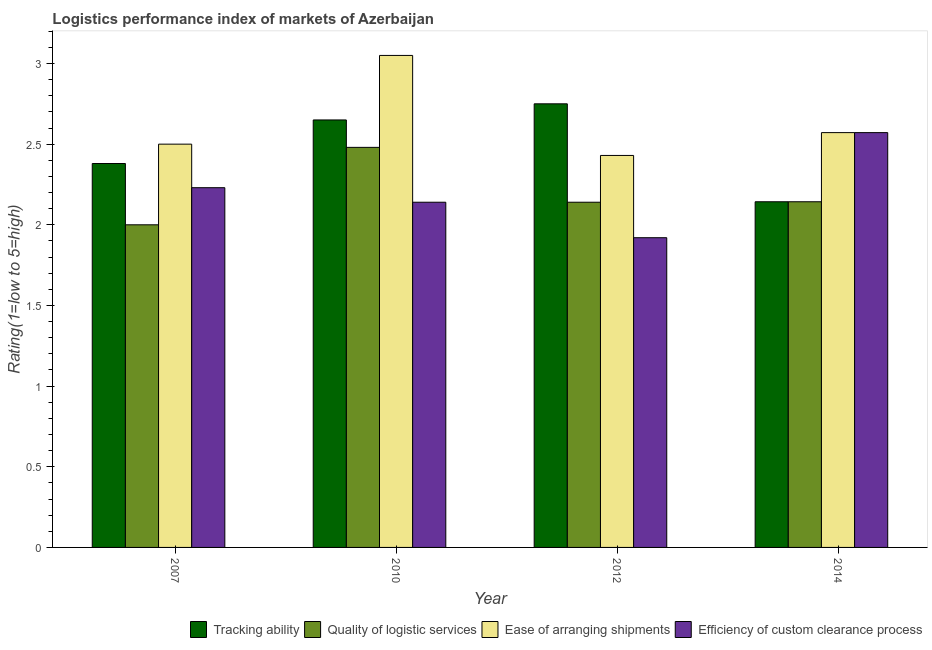How many groups of bars are there?
Keep it short and to the point. 4. Are the number of bars on each tick of the X-axis equal?
Make the answer very short. Yes. How many bars are there on the 1st tick from the left?
Offer a terse response. 4. How many bars are there on the 2nd tick from the right?
Your response must be concise. 4. What is the lpi rating of efficiency of custom clearance process in 2014?
Keep it short and to the point. 2.57. Across all years, what is the maximum lpi rating of ease of arranging shipments?
Offer a terse response. 3.05. Across all years, what is the minimum lpi rating of ease of arranging shipments?
Make the answer very short. 2.43. In which year was the lpi rating of ease of arranging shipments maximum?
Provide a short and direct response. 2010. In which year was the lpi rating of tracking ability minimum?
Your answer should be compact. 2014. What is the total lpi rating of quality of logistic services in the graph?
Provide a short and direct response. 8.76. What is the difference between the lpi rating of efficiency of custom clearance process in 2007 and that in 2010?
Make the answer very short. 0.09. What is the difference between the lpi rating of efficiency of custom clearance process in 2012 and the lpi rating of ease of arranging shipments in 2007?
Offer a very short reply. -0.31. What is the average lpi rating of efficiency of custom clearance process per year?
Your response must be concise. 2.22. In the year 2010, what is the difference between the lpi rating of quality of logistic services and lpi rating of efficiency of custom clearance process?
Your response must be concise. 0. What is the ratio of the lpi rating of efficiency of custom clearance process in 2012 to that in 2014?
Give a very brief answer. 0.75. Is the difference between the lpi rating of efficiency of custom clearance process in 2012 and 2014 greater than the difference between the lpi rating of quality of logistic services in 2012 and 2014?
Provide a succinct answer. No. What is the difference between the highest and the second highest lpi rating of tracking ability?
Ensure brevity in your answer.  0.1. What is the difference between the highest and the lowest lpi rating of quality of logistic services?
Ensure brevity in your answer.  0.48. In how many years, is the lpi rating of tracking ability greater than the average lpi rating of tracking ability taken over all years?
Provide a short and direct response. 2. Is it the case that in every year, the sum of the lpi rating of tracking ability and lpi rating of quality of logistic services is greater than the sum of lpi rating of efficiency of custom clearance process and lpi rating of ease of arranging shipments?
Provide a short and direct response. No. What does the 2nd bar from the left in 2012 represents?
Provide a succinct answer. Quality of logistic services. What does the 3rd bar from the right in 2012 represents?
Your answer should be very brief. Quality of logistic services. Is it the case that in every year, the sum of the lpi rating of tracking ability and lpi rating of quality of logistic services is greater than the lpi rating of ease of arranging shipments?
Offer a terse response. Yes. How many bars are there?
Your answer should be compact. 16. Are all the bars in the graph horizontal?
Your answer should be very brief. No. What is the difference between two consecutive major ticks on the Y-axis?
Make the answer very short. 0.5. How are the legend labels stacked?
Keep it short and to the point. Horizontal. What is the title of the graph?
Keep it short and to the point. Logistics performance index of markets of Azerbaijan. What is the label or title of the Y-axis?
Offer a very short reply. Rating(1=low to 5=high). What is the Rating(1=low to 5=high) of Tracking ability in 2007?
Provide a short and direct response. 2.38. What is the Rating(1=low to 5=high) of Efficiency of custom clearance process in 2007?
Provide a succinct answer. 2.23. What is the Rating(1=low to 5=high) of Tracking ability in 2010?
Provide a short and direct response. 2.65. What is the Rating(1=low to 5=high) in Quality of logistic services in 2010?
Your answer should be compact. 2.48. What is the Rating(1=low to 5=high) of Ease of arranging shipments in 2010?
Ensure brevity in your answer.  3.05. What is the Rating(1=low to 5=high) of Efficiency of custom clearance process in 2010?
Provide a short and direct response. 2.14. What is the Rating(1=low to 5=high) of Tracking ability in 2012?
Give a very brief answer. 2.75. What is the Rating(1=low to 5=high) in Quality of logistic services in 2012?
Make the answer very short. 2.14. What is the Rating(1=low to 5=high) of Ease of arranging shipments in 2012?
Provide a short and direct response. 2.43. What is the Rating(1=low to 5=high) of Efficiency of custom clearance process in 2012?
Your response must be concise. 1.92. What is the Rating(1=low to 5=high) of Tracking ability in 2014?
Ensure brevity in your answer.  2.14. What is the Rating(1=low to 5=high) in Quality of logistic services in 2014?
Make the answer very short. 2.14. What is the Rating(1=low to 5=high) in Ease of arranging shipments in 2014?
Keep it short and to the point. 2.57. What is the Rating(1=low to 5=high) in Efficiency of custom clearance process in 2014?
Give a very brief answer. 2.57. Across all years, what is the maximum Rating(1=low to 5=high) of Tracking ability?
Give a very brief answer. 2.75. Across all years, what is the maximum Rating(1=low to 5=high) in Quality of logistic services?
Your answer should be compact. 2.48. Across all years, what is the maximum Rating(1=low to 5=high) of Ease of arranging shipments?
Offer a terse response. 3.05. Across all years, what is the maximum Rating(1=low to 5=high) in Efficiency of custom clearance process?
Your response must be concise. 2.57. Across all years, what is the minimum Rating(1=low to 5=high) in Tracking ability?
Keep it short and to the point. 2.14. Across all years, what is the minimum Rating(1=low to 5=high) in Ease of arranging shipments?
Offer a very short reply. 2.43. Across all years, what is the minimum Rating(1=low to 5=high) of Efficiency of custom clearance process?
Offer a terse response. 1.92. What is the total Rating(1=low to 5=high) of Tracking ability in the graph?
Your answer should be very brief. 9.92. What is the total Rating(1=low to 5=high) in Quality of logistic services in the graph?
Your answer should be compact. 8.76. What is the total Rating(1=low to 5=high) in Ease of arranging shipments in the graph?
Your answer should be compact. 10.55. What is the total Rating(1=low to 5=high) of Efficiency of custom clearance process in the graph?
Ensure brevity in your answer.  8.86. What is the difference between the Rating(1=low to 5=high) of Tracking ability in 2007 and that in 2010?
Your answer should be very brief. -0.27. What is the difference between the Rating(1=low to 5=high) of Quality of logistic services in 2007 and that in 2010?
Your response must be concise. -0.48. What is the difference between the Rating(1=low to 5=high) of Ease of arranging shipments in 2007 and that in 2010?
Give a very brief answer. -0.55. What is the difference between the Rating(1=low to 5=high) in Efficiency of custom clearance process in 2007 and that in 2010?
Offer a very short reply. 0.09. What is the difference between the Rating(1=low to 5=high) of Tracking ability in 2007 and that in 2012?
Provide a short and direct response. -0.37. What is the difference between the Rating(1=low to 5=high) in Quality of logistic services in 2007 and that in 2012?
Your answer should be compact. -0.14. What is the difference between the Rating(1=low to 5=high) in Ease of arranging shipments in 2007 and that in 2012?
Provide a succinct answer. 0.07. What is the difference between the Rating(1=low to 5=high) in Efficiency of custom clearance process in 2007 and that in 2012?
Your answer should be compact. 0.31. What is the difference between the Rating(1=low to 5=high) in Tracking ability in 2007 and that in 2014?
Offer a terse response. 0.24. What is the difference between the Rating(1=low to 5=high) of Quality of logistic services in 2007 and that in 2014?
Offer a very short reply. -0.14. What is the difference between the Rating(1=low to 5=high) in Ease of arranging shipments in 2007 and that in 2014?
Offer a very short reply. -0.07. What is the difference between the Rating(1=low to 5=high) of Efficiency of custom clearance process in 2007 and that in 2014?
Provide a succinct answer. -0.34. What is the difference between the Rating(1=low to 5=high) in Tracking ability in 2010 and that in 2012?
Provide a succinct answer. -0.1. What is the difference between the Rating(1=low to 5=high) of Quality of logistic services in 2010 and that in 2012?
Your answer should be very brief. 0.34. What is the difference between the Rating(1=low to 5=high) in Ease of arranging shipments in 2010 and that in 2012?
Make the answer very short. 0.62. What is the difference between the Rating(1=low to 5=high) of Efficiency of custom clearance process in 2010 and that in 2012?
Your answer should be very brief. 0.22. What is the difference between the Rating(1=low to 5=high) in Tracking ability in 2010 and that in 2014?
Keep it short and to the point. 0.51. What is the difference between the Rating(1=low to 5=high) of Quality of logistic services in 2010 and that in 2014?
Your answer should be compact. 0.34. What is the difference between the Rating(1=low to 5=high) of Ease of arranging shipments in 2010 and that in 2014?
Make the answer very short. 0.48. What is the difference between the Rating(1=low to 5=high) in Efficiency of custom clearance process in 2010 and that in 2014?
Provide a short and direct response. -0.43. What is the difference between the Rating(1=low to 5=high) in Tracking ability in 2012 and that in 2014?
Keep it short and to the point. 0.61. What is the difference between the Rating(1=low to 5=high) of Quality of logistic services in 2012 and that in 2014?
Offer a terse response. -0. What is the difference between the Rating(1=low to 5=high) of Ease of arranging shipments in 2012 and that in 2014?
Your response must be concise. -0.14. What is the difference between the Rating(1=low to 5=high) in Efficiency of custom clearance process in 2012 and that in 2014?
Provide a short and direct response. -0.65. What is the difference between the Rating(1=low to 5=high) of Tracking ability in 2007 and the Rating(1=low to 5=high) of Ease of arranging shipments in 2010?
Your answer should be compact. -0.67. What is the difference between the Rating(1=low to 5=high) of Tracking ability in 2007 and the Rating(1=low to 5=high) of Efficiency of custom clearance process in 2010?
Provide a short and direct response. 0.24. What is the difference between the Rating(1=low to 5=high) in Quality of logistic services in 2007 and the Rating(1=low to 5=high) in Ease of arranging shipments in 2010?
Make the answer very short. -1.05. What is the difference between the Rating(1=low to 5=high) of Quality of logistic services in 2007 and the Rating(1=low to 5=high) of Efficiency of custom clearance process in 2010?
Offer a very short reply. -0.14. What is the difference between the Rating(1=low to 5=high) of Ease of arranging shipments in 2007 and the Rating(1=low to 5=high) of Efficiency of custom clearance process in 2010?
Your response must be concise. 0.36. What is the difference between the Rating(1=low to 5=high) in Tracking ability in 2007 and the Rating(1=low to 5=high) in Quality of logistic services in 2012?
Make the answer very short. 0.24. What is the difference between the Rating(1=low to 5=high) of Tracking ability in 2007 and the Rating(1=low to 5=high) of Efficiency of custom clearance process in 2012?
Make the answer very short. 0.46. What is the difference between the Rating(1=low to 5=high) of Quality of logistic services in 2007 and the Rating(1=low to 5=high) of Ease of arranging shipments in 2012?
Give a very brief answer. -0.43. What is the difference between the Rating(1=low to 5=high) in Ease of arranging shipments in 2007 and the Rating(1=low to 5=high) in Efficiency of custom clearance process in 2012?
Make the answer very short. 0.58. What is the difference between the Rating(1=low to 5=high) of Tracking ability in 2007 and the Rating(1=low to 5=high) of Quality of logistic services in 2014?
Provide a succinct answer. 0.24. What is the difference between the Rating(1=low to 5=high) in Tracking ability in 2007 and the Rating(1=low to 5=high) in Ease of arranging shipments in 2014?
Your answer should be very brief. -0.19. What is the difference between the Rating(1=low to 5=high) of Tracking ability in 2007 and the Rating(1=low to 5=high) of Efficiency of custom clearance process in 2014?
Provide a succinct answer. -0.19. What is the difference between the Rating(1=low to 5=high) in Quality of logistic services in 2007 and the Rating(1=low to 5=high) in Ease of arranging shipments in 2014?
Your response must be concise. -0.57. What is the difference between the Rating(1=low to 5=high) in Quality of logistic services in 2007 and the Rating(1=low to 5=high) in Efficiency of custom clearance process in 2014?
Provide a short and direct response. -0.57. What is the difference between the Rating(1=low to 5=high) in Ease of arranging shipments in 2007 and the Rating(1=low to 5=high) in Efficiency of custom clearance process in 2014?
Offer a very short reply. -0.07. What is the difference between the Rating(1=low to 5=high) in Tracking ability in 2010 and the Rating(1=low to 5=high) in Quality of logistic services in 2012?
Keep it short and to the point. 0.51. What is the difference between the Rating(1=low to 5=high) of Tracking ability in 2010 and the Rating(1=low to 5=high) of Ease of arranging shipments in 2012?
Make the answer very short. 0.22. What is the difference between the Rating(1=low to 5=high) of Tracking ability in 2010 and the Rating(1=low to 5=high) of Efficiency of custom clearance process in 2012?
Keep it short and to the point. 0.73. What is the difference between the Rating(1=low to 5=high) in Quality of logistic services in 2010 and the Rating(1=low to 5=high) in Efficiency of custom clearance process in 2012?
Your answer should be very brief. 0.56. What is the difference between the Rating(1=low to 5=high) of Ease of arranging shipments in 2010 and the Rating(1=low to 5=high) of Efficiency of custom clearance process in 2012?
Offer a terse response. 1.13. What is the difference between the Rating(1=low to 5=high) of Tracking ability in 2010 and the Rating(1=low to 5=high) of Quality of logistic services in 2014?
Provide a short and direct response. 0.51. What is the difference between the Rating(1=low to 5=high) of Tracking ability in 2010 and the Rating(1=low to 5=high) of Ease of arranging shipments in 2014?
Provide a short and direct response. 0.08. What is the difference between the Rating(1=low to 5=high) of Tracking ability in 2010 and the Rating(1=low to 5=high) of Efficiency of custom clearance process in 2014?
Offer a terse response. 0.08. What is the difference between the Rating(1=low to 5=high) of Quality of logistic services in 2010 and the Rating(1=low to 5=high) of Ease of arranging shipments in 2014?
Keep it short and to the point. -0.09. What is the difference between the Rating(1=low to 5=high) in Quality of logistic services in 2010 and the Rating(1=low to 5=high) in Efficiency of custom clearance process in 2014?
Keep it short and to the point. -0.09. What is the difference between the Rating(1=low to 5=high) of Ease of arranging shipments in 2010 and the Rating(1=low to 5=high) of Efficiency of custom clearance process in 2014?
Ensure brevity in your answer.  0.48. What is the difference between the Rating(1=low to 5=high) of Tracking ability in 2012 and the Rating(1=low to 5=high) of Quality of logistic services in 2014?
Your answer should be very brief. 0.61. What is the difference between the Rating(1=low to 5=high) of Tracking ability in 2012 and the Rating(1=low to 5=high) of Ease of arranging shipments in 2014?
Your answer should be compact. 0.18. What is the difference between the Rating(1=low to 5=high) in Tracking ability in 2012 and the Rating(1=low to 5=high) in Efficiency of custom clearance process in 2014?
Your answer should be compact. 0.18. What is the difference between the Rating(1=low to 5=high) of Quality of logistic services in 2012 and the Rating(1=low to 5=high) of Ease of arranging shipments in 2014?
Ensure brevity in your answer.  -0.43. What is the difference between the Rating(1=low to 5=high) of Quality of logistic services in 2012 and the Rating(1=low to 5=high) of Efficiency of custom clearance process in 2014?
Provide a succinct answer. -0.43. What is the difference between the Rating(1=low to 5=high) in Ease of arranging shipments in 2012 and the Rating(1=low to 5=high) in Efficiency of custom clearance process in 2014?
Your response must be concise. -0.14. What is the average Rating(1=low to 5=high) in Tracking ability per year?
Provide a short and direct response. 2.48. What is the average Rating(1=low to 5=high) in Quality of logistic services per year?
Ensure brevity in your answer.  2.19. What is the average Rating(1=low to 5=high) of Ease of arranging shipments per year?
Ensure brevity in your answer.  2.64. What is the average Rating(1=low to 5=high) in Efficiency of custom clearance process per year?
Your response must be concise. 2.22. In the year 2007, what is the difference between the Rating(1=low to 5=high) of Tracking ability and Rating(1=low to 5=high) of Quality of logistic services?
Your answer should be compact. 0.38. In the year 2007, what is the difference between the Rating(1=low to 5=high) in Tracking ability and Rating(1=low to 5=high) in Ease of arranging shipments?
Your response must be concise. -0.12. In the year 2007, what is the difference between the Rating(1=low to 5=high) in Tracking ability and Rating(1=low to 5=high) in Efficiency of custom clearance process?
Your response must be concise. 0.15. In the year 2007, what is the difference between the Rating(1=low to 5=high) in Quality of logistic services and Rating(1=low to 5=high) in Efficiency of custom clearance process?
Your answer should be compact. -0.23. In the year 2007, what is the difference between the Rating(1=low to 5=high) in Ease of arranging shipments and Rating(1=low to 5=high) in Efficiency of custom clearance process?
Ensure brevity in your answer.  0.27. In the year 2010, what is the difference between the Rating(1=low to 5=high) in Tracking ability and Rating(1=low to 5=high) in Quality of logistic services?
Your answer should be very brief. 0.17. In the year 2010, what is the difference between the Rating(1=low to 5=high) of Tracking ability and Rating(1=low to 5=high) of Ease of arranging shipments?
Offer a very short reply. -0.4. In the year 2010, what is the difference between the Rating(1=low to 5=high) in Tracking ability and Rating(1=low to 5=high) in Efficiency of custom clearance process?
Ensure brevity in your answer.  0.51. In the year 2010, what is the difference between the Rating(1=low to 5=high) of Quality of logistic services and Rating(1=low to 5=high) of Ease of arranging shipments?
Provide a succinct answer. -0.57. In the year 2010, what is the difference between the Rating(1=low to 5=high) in Quality of logistic services and Rating(1=low to 5=high) in Efficiency of custom clearance process?
Keep it short and to the point. 0.34. In the year 2010, what is the difference between the Rating(1=low to 5=high) in Ease of arranging shipments and Rating(1=low to 5=high) in Efficiency of custom clearance process?
Make the answer very short. 0.91. In the year 2012, what is the difference between the Rating(1=low to 5=high) of Tracking ability and Rating(1=low to 5=high) of Quality of logistic services?
Offer a terse response. 0.61. In the year 2012, what is the difference between the Rating(1=low to 5=high) of Tracking ability and Rating(1=low to 5=high) of Ease of arranging shipments?
Your response must be concise. 0.32. In the year 2012, what is the difference between the Rating(1=low to 5=high) of Tracking ability and Rating(1=low to 5=high) of Efficiency of custom clearance process?
Your answer should be very brief. 0.83. In the year 2012, what is the difference between the Rating(1=low to 5=high) in Quality of logistic services and Rating(1=low to 5=high) in Ease of arranging shipments?
Your response must be concise. -0.29. In the year 2012, what is the difference between the Rating(1=low to 5=high) in Quality of logistic services and Rating(1=low to 5=high) in Efficiency of custom clearance process?
Ensure brevity in your answer.  0.22. In the year 2012, what is the difference between the Rating(1=low to 5=high) in Ease of arranging shipments and Rating(1=low to 5=high) in Efficiency of custom clearance process?
Provide a short and direct response. 0.51. In the year 2014, what is the difference between the Rating(1=low to 5=high) of Tracking ability and Rating(1=low to 5=high) of Ease of arranging shipments?
Keep it short and to the point. -0.43. In the year 2014, what is the difference between the Rating(1=low to 5=high) in Tracking ability and Rating(1=low to 5=high) in Efficiency of custom clearance process?
Ensure brevity in your answer.  -0.43. In the year 2014, what is the difference between the Rating(1=low to 5=high) of Quality of logistic services and Rating(1=low to 5=high) of Ease of arranging shipments?
Make the answer very short. -0.43. In the year 2014, what is the difference between the Rating(1=low to 5=high) in Quality of logistic services and Rating(1=low to 5=high) in Efficiency of custom clearance process?
Your response must be concise. -0.43. What is the ratio of the Rating(1=low to 5=high) in Tracking ability in 2007 to that in 2010?
Your answer should be very brief. 0.9. What is the ratio of the Rating(1=low to 5=high) in Quality of logistic services in 2007 to that in 2010?
Make the answer very short. 0.81. What is the ratio of the Rating(1=low to 5=high) in Ease of arranging shipments in 2007 to that in 2010?
Ensure brevity in your answer.  0.82. What is the ratio of the Rating(1=low to 5=high) in Efficiency of custom clearance process in 2007 to that in 2010?
Provide a short and direct response. 1.04. What is the ratio of the Rating(1=low to 5=high) of Tracking ability in 2007 to that in 2012?
Provide a short and direct response. 0.87. What is the ratio of the Rating(1=low to 5=high) in Quality of logistic services in 2007 to that in 2012?
Provide a succinct answer. 0.93. What is the ratio of the Rating(1=low to 5=high) of Ease of arranging shipments in 2007 to that in 2012?
Your response must be concise. 1.03. What is the ratio of the Rating(1=low to 5=high) of Efficiency of custom clearance process in 2007 to that in 2012?
Provide a short and direct response. 1.16. What is the ratio of the Rating(1=low to 5=high) in Tracking ability in 2007 to that in 2014?
Give a very brief answer. 1.11. What is the ratio of the Rating(1=low to 5=high) in Ease of arranging shipments in 2007 to that in 2014?
Offer a terse response. 0.97. What is the ratio of the Rating(1=low to 5=high) of Efficiency of custom clearance process in 2007 to that in 2014?
Your answer should be very brief. 0.87. What is the ratio of the Rating(1=low to 5=high) of Tracking ability in 2010 to that in 2012?
Your response must be concise. 0.96. What is the ratio of the Rating(1=low to 5=high) in Quality of logistic services in 2010 to that in 2012?
Give a very brief answer. 1.16. What is the ratio of the Rating(1=low to 5=high) of Ease of arranging shipments in 2010 to that in 2012?
Offer a terse response. 1.26. What is the ratio of the Rating(1=low to 5=high) of Efficiency of custom clearance process in 2010 to that in 2012?
Ensure brevity in your answer.  1.11. What is the ratio of the Rating(1=low to 5=high) in Tracking ability in 2010 to that in 2014?
Keep it short and to the point. 1.24. What is the ratio of the Rating(1=low to 5=high) of Quality of logistic services in 2010 to that in 2014?
Offer a very short reply. 1.16. What is the ratio of the Rating(1=low to 5=high) of Ease of arranging shipments in 2010 to that in 2014?
Keep it short and to the point. 1.19. What is the ratio of the Rating(1=low to 5=high) of Efficiency of custom clearance process in 2010 to that in 2014?
Ensure brevity in your answer.  0.83. What is the ratio of the Rating(1=low to 5=high) in Tracking ability in 2012 to that in 2014?
Your answer should be very brief. 1.28. What is the ratio of the Rating(1=low to 5=high) of Ease of arranging shipments in 2012 to that in 2014?
Offer a terse response. 0.94. What is the ratio of the Rating(1=low to 5=high) in Efficiency of custom clearance process in 2012 to that in 2014?
Provide a short and direct response. 0.75. What is the difference between the highest and the second highest Rating(1=low to 5=high) in Quality of logistic services?
Provide a short and direct response. 0.34. What is the difference between the highest and the second highest Rating(1=low to 5=high) of Ease of arranging shipments?
Keep it short and to the point. 0.48. What is the difference between the highest and the second highest Rating(1=low to 5=high) in Efficiency of custom clearance process?
Ensure brevity in your answer.  0.34. What is the difference between the highest and the lowest Rating(1=low to 5=high) in Tracking ability?
Make the answer very short. 0.61. What is the difference between the highest and the lowest Rating(1=low to 5=high) of Quality of logistic services?
Make the answer very short. 0.48. What is the difference between the highest and the lowest Rating(1=low to 5=high) of Ease of arranging shipments?
Ensure brevity in your answer.  0.62. What is the difference between the highest and the lowest Rating(1=low to 5=high) in Efficiency of custom clearance process?
Make the answer very short. 0.65. 